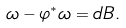<formula> <loc_0><loc_0><loc_500><loc_500>\omega - \varphi ^ { \ast } \omega = d B .</formula> 